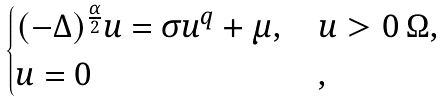<formula> <loc_0><loc_0><loc_500><loc_500>\begin{cases} ( - \Delta ) ^ { \frac { \alpha } { 2 } } u = \sigma u ^ { q } + \mu , \, & u > 0 \, \Omega , \\ u = 0 & , \end{cases}</formula> 